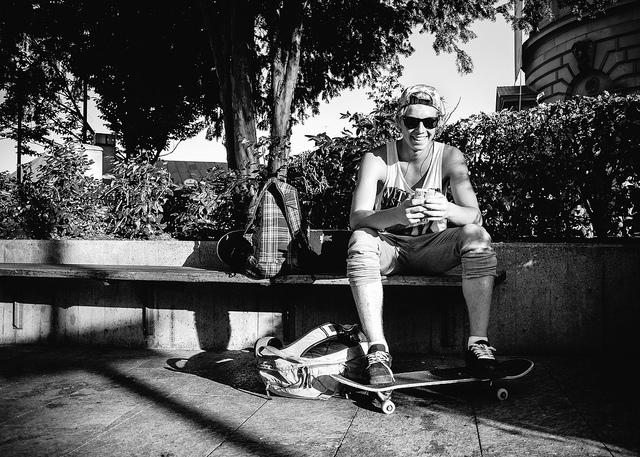What's the man taking a break from?

Choices:
A) skateboarding
B) wrestling
C) basketball
D) volleyball skateboarding 